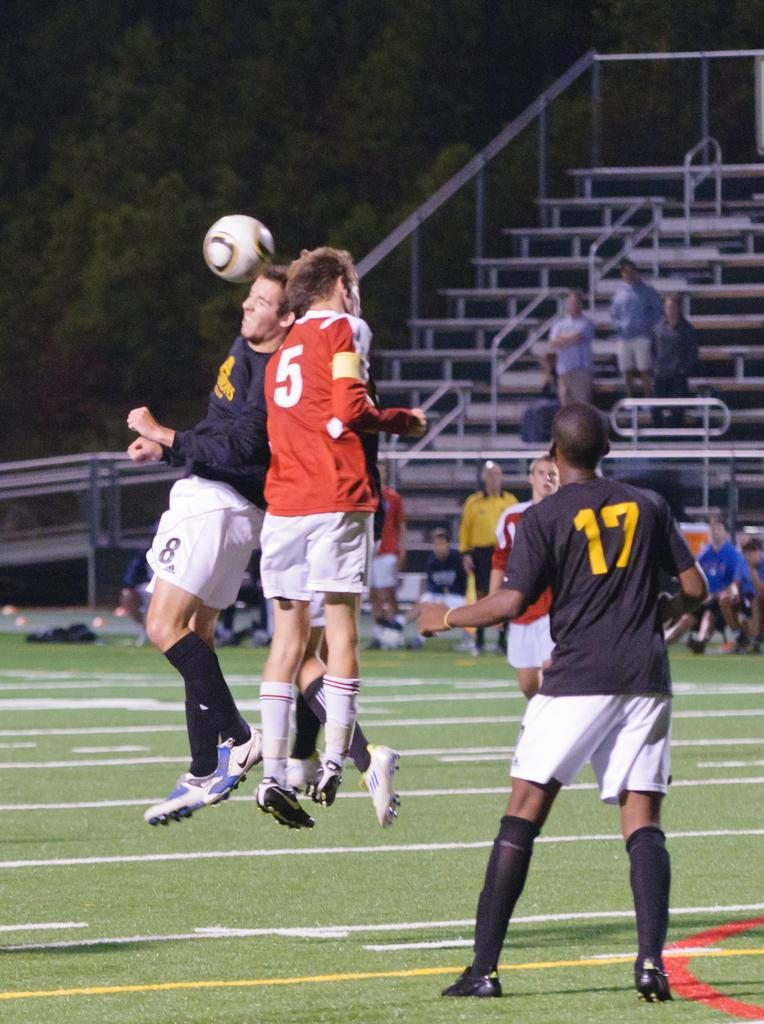<image>
Summarize the visual content of the image. A soccer match were number 5 in red is involved in a play. 